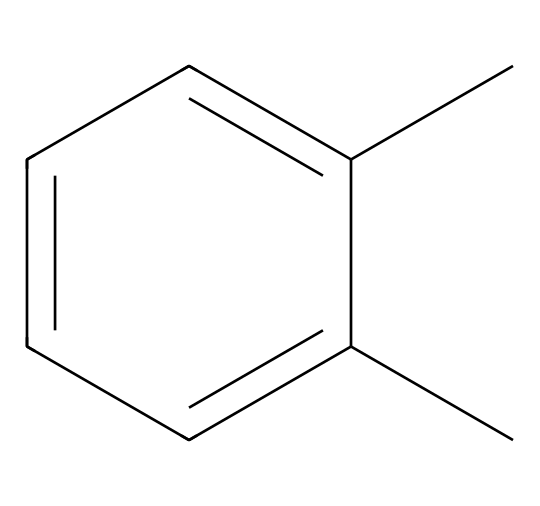What is the name of this chemical? The SMILES representation given is "Cc1ccccc1C", which corresponds to xylene, a solvent commonly used in the film industry. The structure indicates a biphenyl component, characteristic of xylene.
Answer: xylene How many carbon atoms are present in xylene? By analyzing the SMILES representation, "Cc1ccccc1C", we see there are a total of 8 carbon atoms (1 from the "C" at the beginning and 7 from the aromatic ring).
Answer: 8 What type of bonding is primarily present in xylene? The predominant type of bonding in xylene is covalent bonding, as seen in the connections between carbon atoms in the structure, both within the aromatic ring and the branches.
Answer: covalent Is xylene a hazardous chemical? Xylene is classified as hazardous due to its toxic effects, including respiratory irritation and potential effects on the nervous system, recognized in safety data sheets.
Answer: yes What functional groups are present in xylene? Xylene is an aromatic compound and does not contain any functional groups such as hydroxyl or carboxyl groups; it mainly consists of simple hydrocarbon chains and rings.
Answer: none What solvent properties does xylene exhibit? Xylene has good solvency for many organic materials, making it suitable for use as a solvent in film development, consistent with its structure as a non-polar organic solvent.
Answer: good solvency 